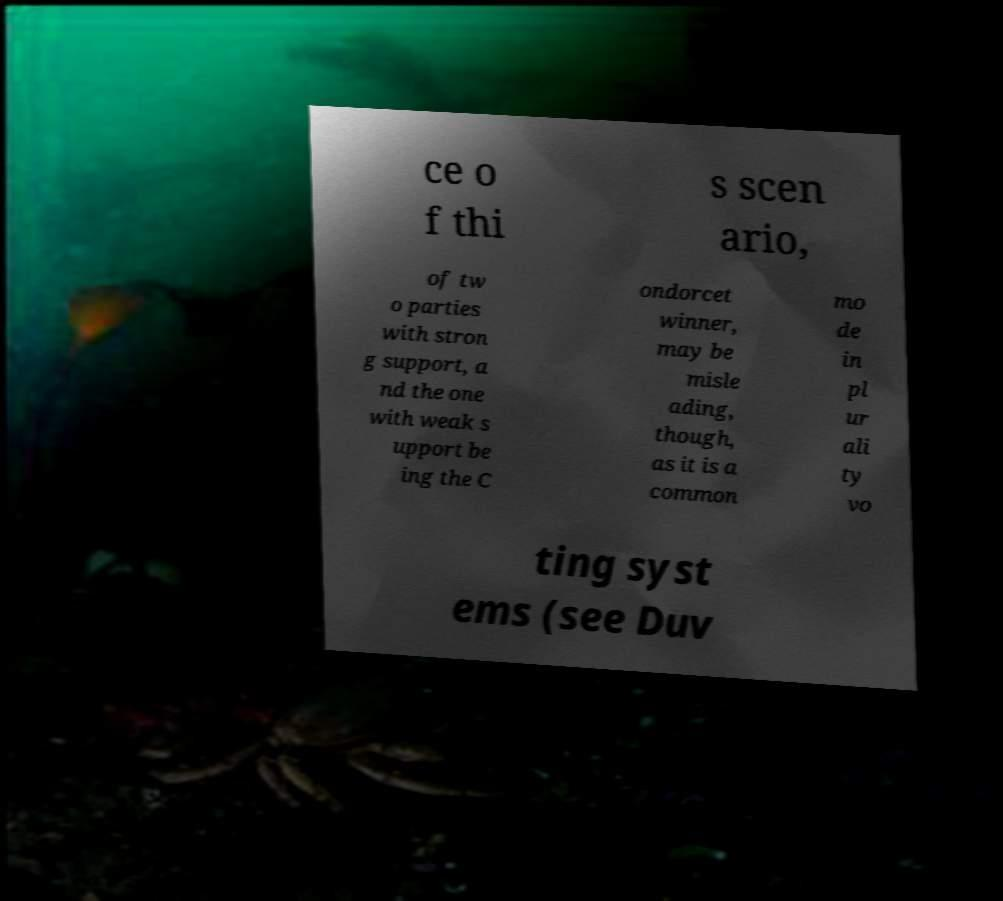Could you assist in decoding the text presented in this image and type it out clearly? ce o f thi s scen ario, of tw o parties with stron g support, a nd the one with weak s upport be ing the C ondorcet winner, may be misle ading, though, as it is a common mo de in pl ur ali ty vo ting syst ems (see Duv 